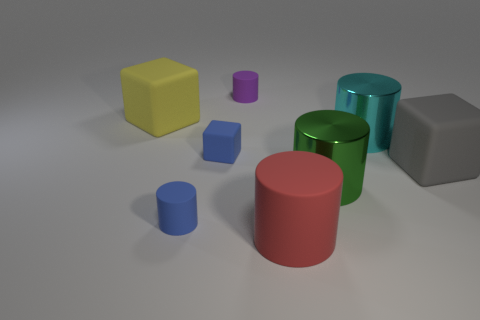Subtract all green cylinders. How many cylinders are left? 4 Subtract all big green cylinders. How many cylinders are left? 4 Subtract all brown cylinders. Subtract all blue balls. How many cylinders are left? 5 Add 1 green shiny cylinders. How many objects exist? 9 Subtract all cylinders. How many objects are left? 3 Subtract 0 brown cubes. How many objects are left? 8 Subtract all red matte cylinders. Subtract all blue rubber objects. How many objects are left? 5 Add 1 rubber objects. How many rubber objects are left? 7 Add 1 gray matte blocks. How many gray matte blocks exist? 2 